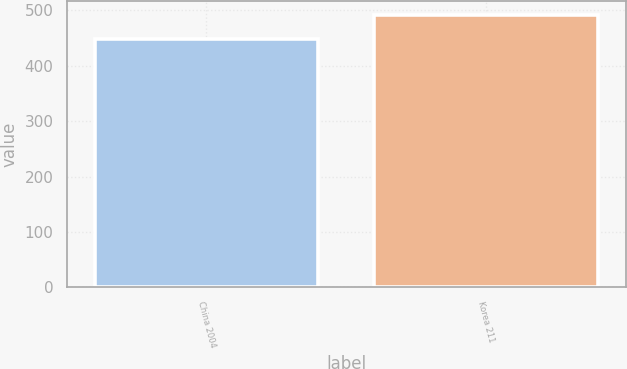Convert chart to OTSL. <chart><loc_0><loc_0><loc_500><loc_500><bar_chart><fcel>China 2004<fcel>Korea 211<nl><fcel>449<fcel>492<nl></chart> 